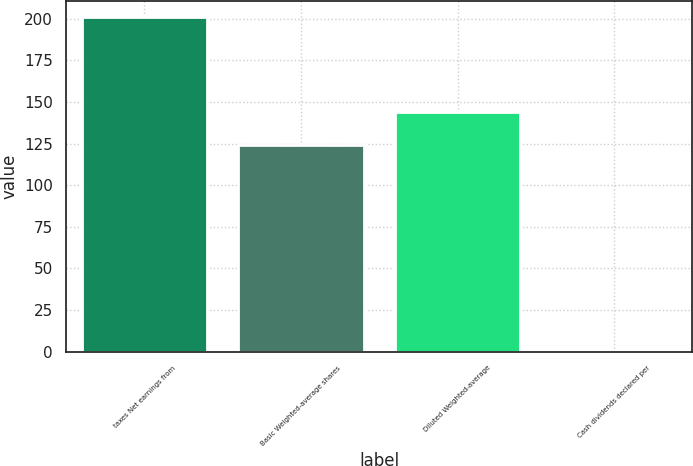<chart> <loc_0><loc_0><loc_500><loc_500><bar_chart><fcel>taxes Net earnings from<fcel>Basic Weighted-average shares<fcel>Diluted Weighted-average<fcel>Cash dividends declared per<nl><fcel>200.9<fcel>124.1<fcel>144.13<fcel>0.64<nl></chart> 